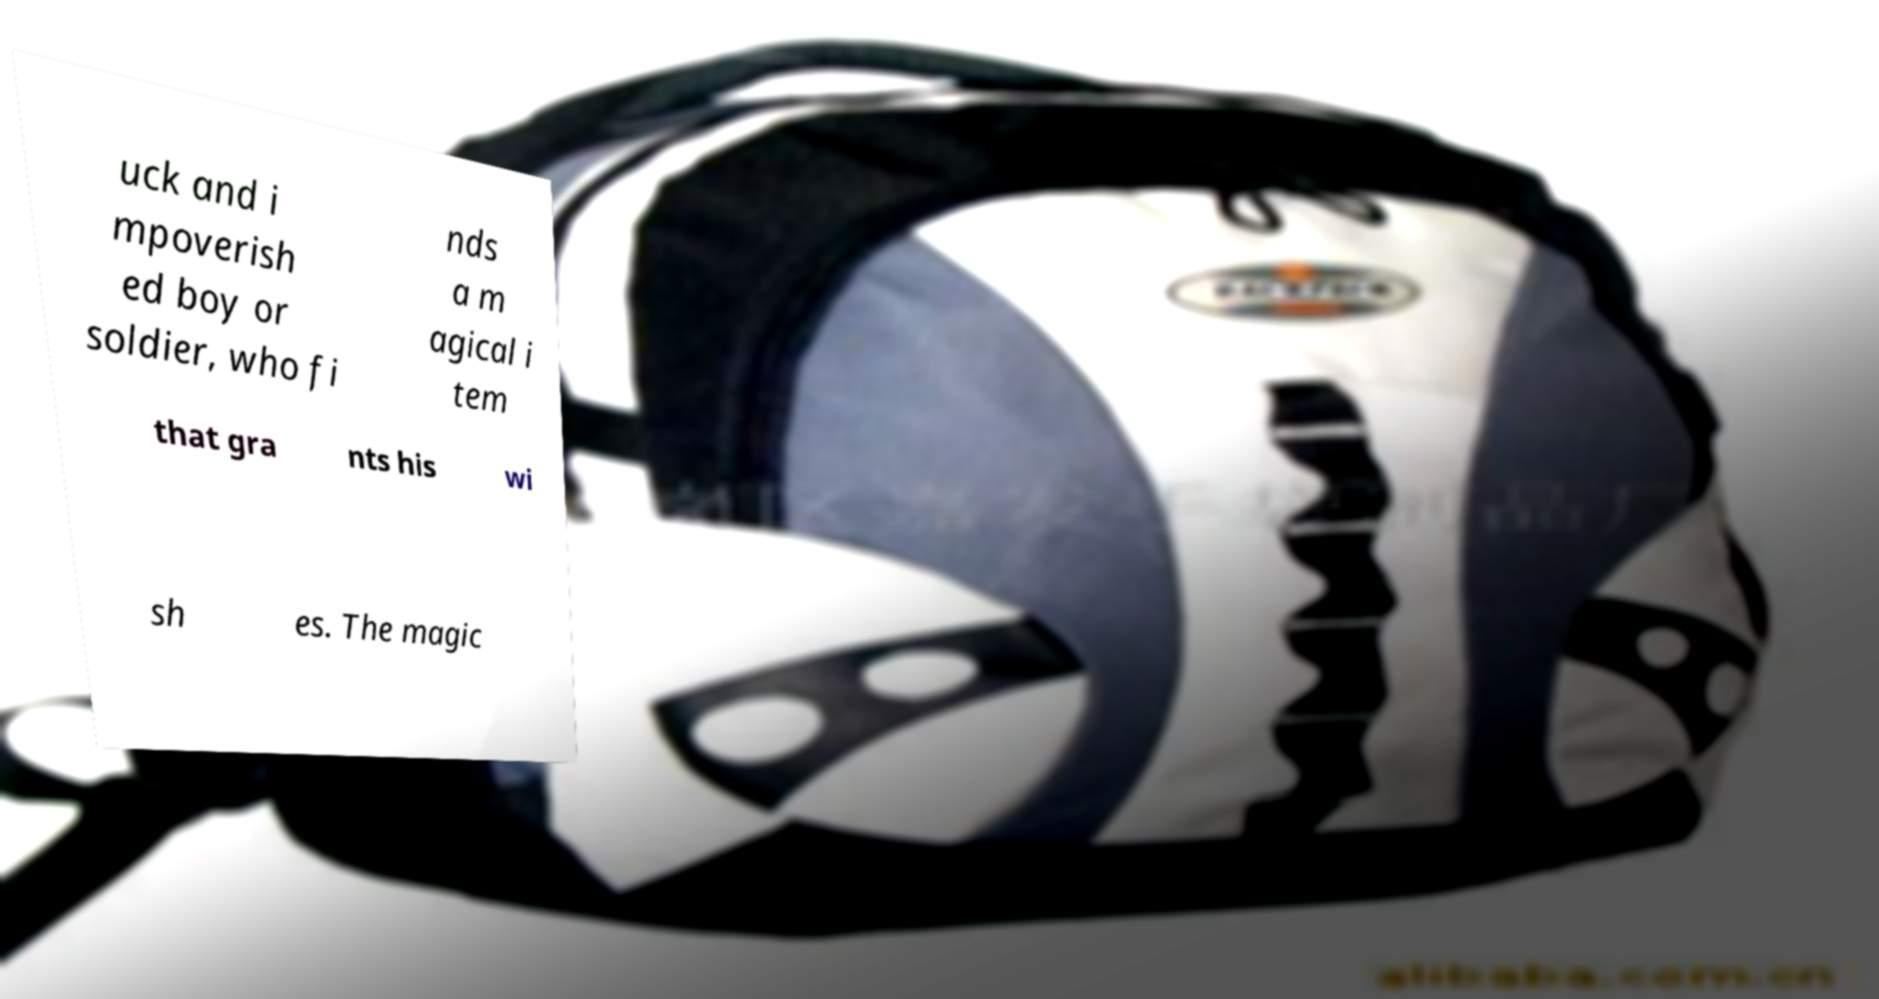Can you read and provide the text displayed in the image?This photo seems to have some interesting text. Can you extract and type it out for me? uck and i mpoverish ed boy or soldier, who fi nds a m agical i tem that gra nts his wi sh es. The magic 